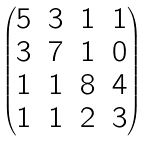<formula> <loc_0><loc_0><loc_500><loc_500>\begin{pmatrix} 5 & 3 & 1 & 1 \\ 3 & 7 & 1 & 0 \\ 1 & 1 & 8 & 4 \\ 1 & 1 & 2 & 3 \end{pmatrix}</formula> 